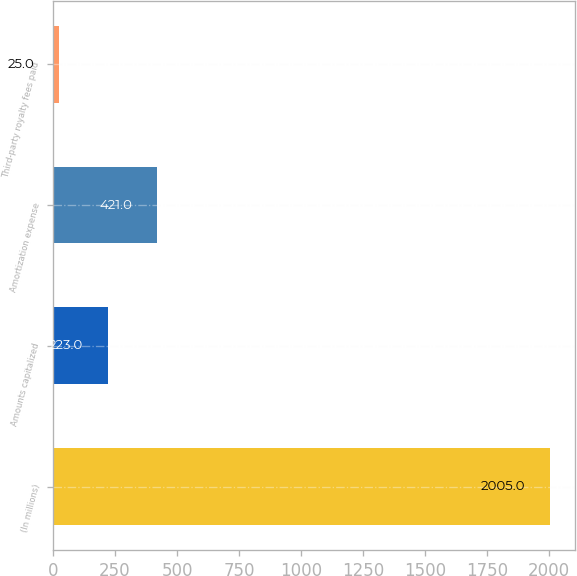<chart> <loc_0><loc_0><loc_500><loc_500><bar_chart><fcel>(In millions)<fcel>Amounts capitalized<fcel>Amortization expense<fcel>Third-party royalty fees paid<nl><fcel>2005<fcel>223<fcel>421<fcel>25<nl></chart> 